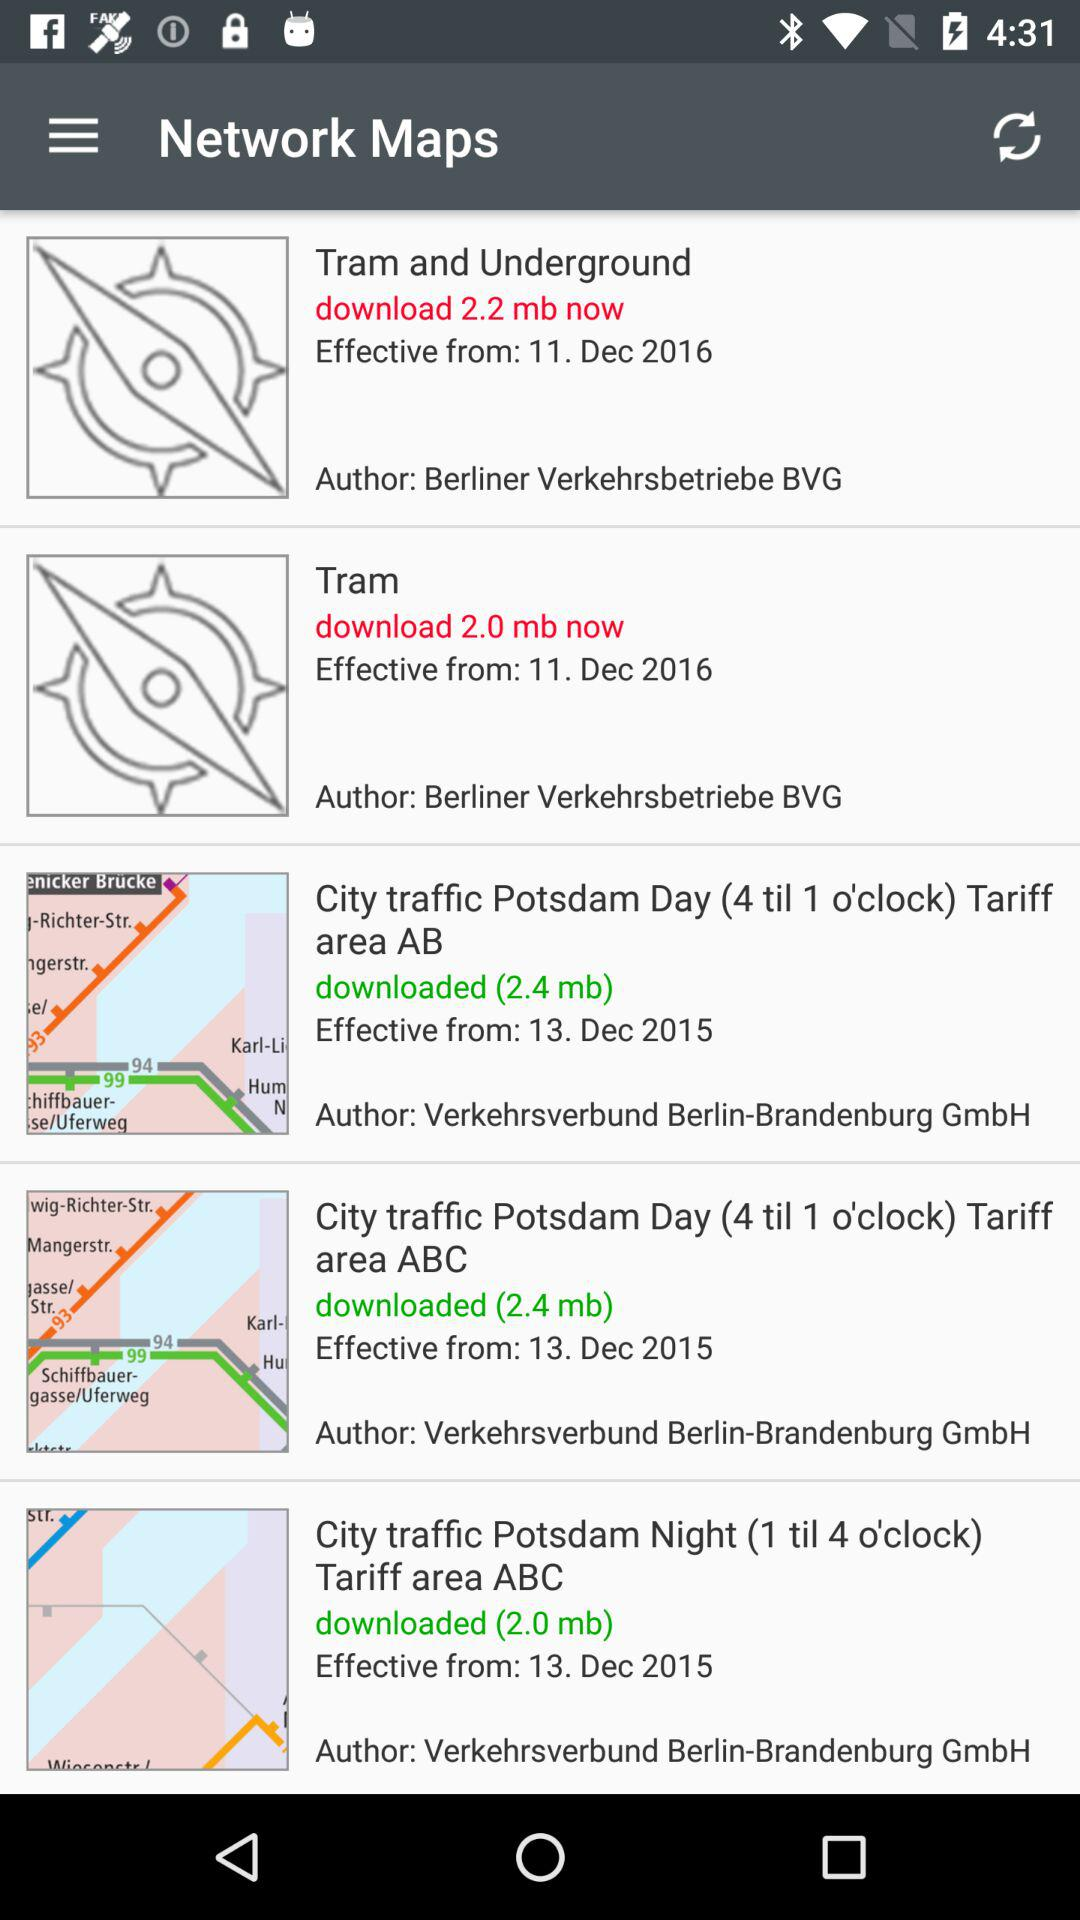Who is the author of "Tram"? The author is Berliner Verkehrsbetriebe BVG. 